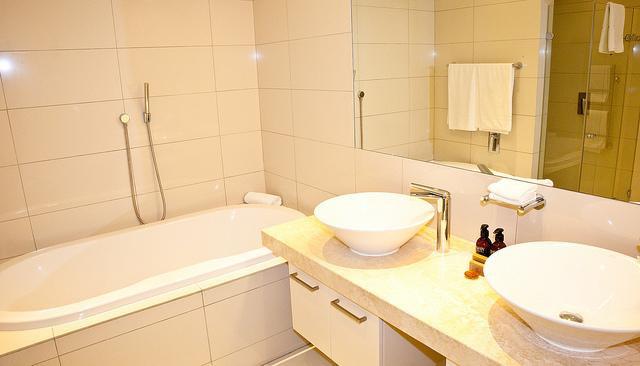What type of sinks are these?

Choices:
A) top mount
B) under mount
C) bowl sinks
D) drop sinks bowl sinks 